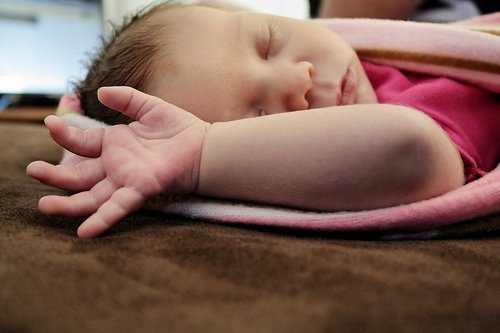<image>
Is there a baby above the table? No. The baby is not positioned above the table. The vertical arrangement shows a different relationship. 